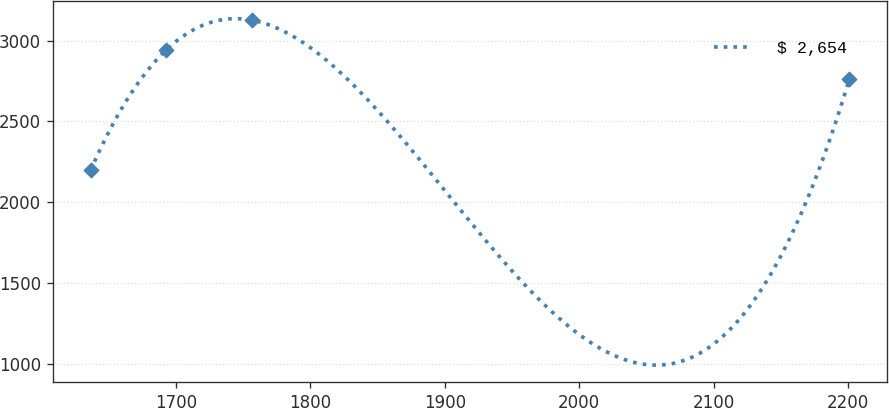<chart> <loc_0><loc_0><loc_500><loc_500><line_chart><ecel><fcel>$ 2,654<nl><fcel>1636.42<fcel>2196.48<nl><fcel>1692.88<fcel>2944.37<nl><fcel>1756.89<fcel>3127.15<nl><fcel>2201.04<fcel>2761.72<nl></chart> 